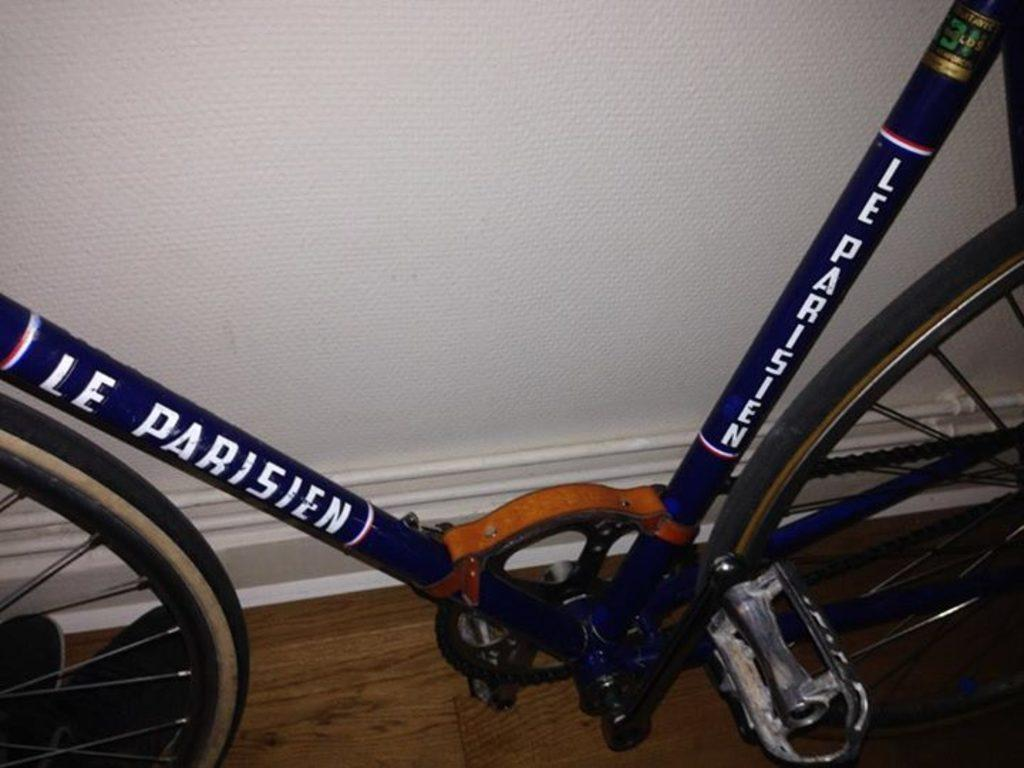What is partially visible in the image? Partial parts of a cycle are visible in the image. What is located behind the cycle in the image? There is a wall behind the cycle in the image. How many songs can be heard playing in the background of the image? There are no songs or sounds present in the image, as it is a still image. 